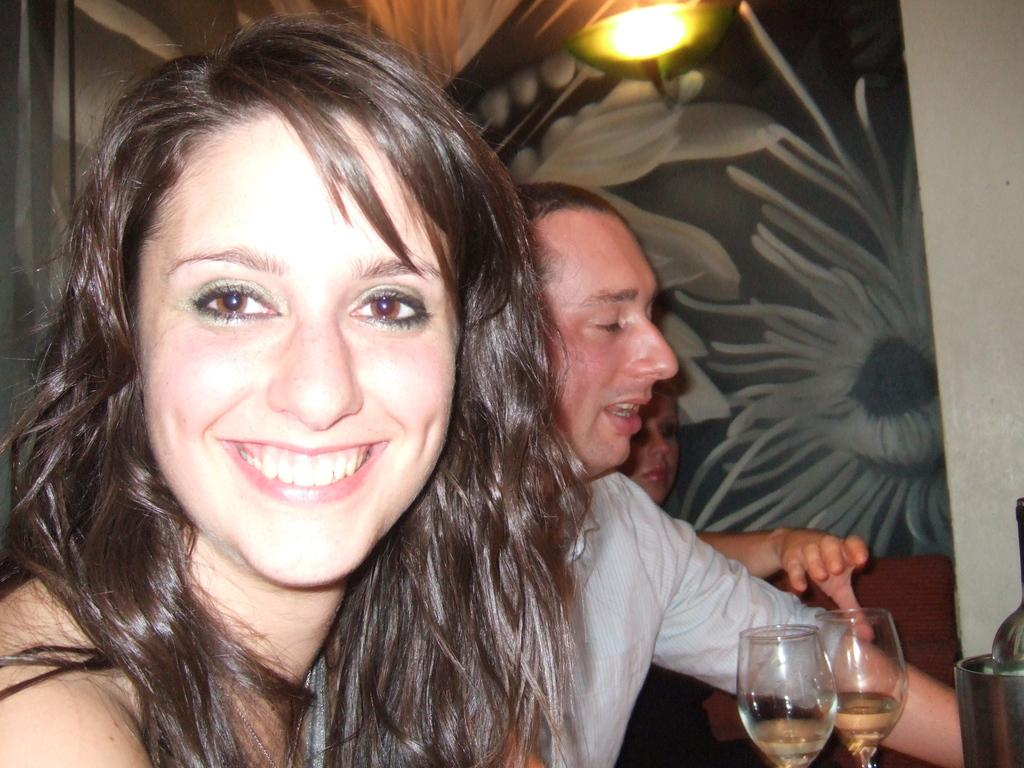What are the people in the image wearing? The people in the image are wearing clothes. What can be seen on the table in the image? There are two wine glasses on the table in the image. What is the expression of the woman in the image? The woman in the image is smiling. What is providing illumination in the image? There is a light in the image. What is the background of the image made of? There is a wall in the image. What is the container holding in the image? There is a bottle in a container in the image. What type of food is being prepared on the match in the image? There is no match or food preparation visible in the image. How many windows can be seen in the image? There are no windows present in the image. 